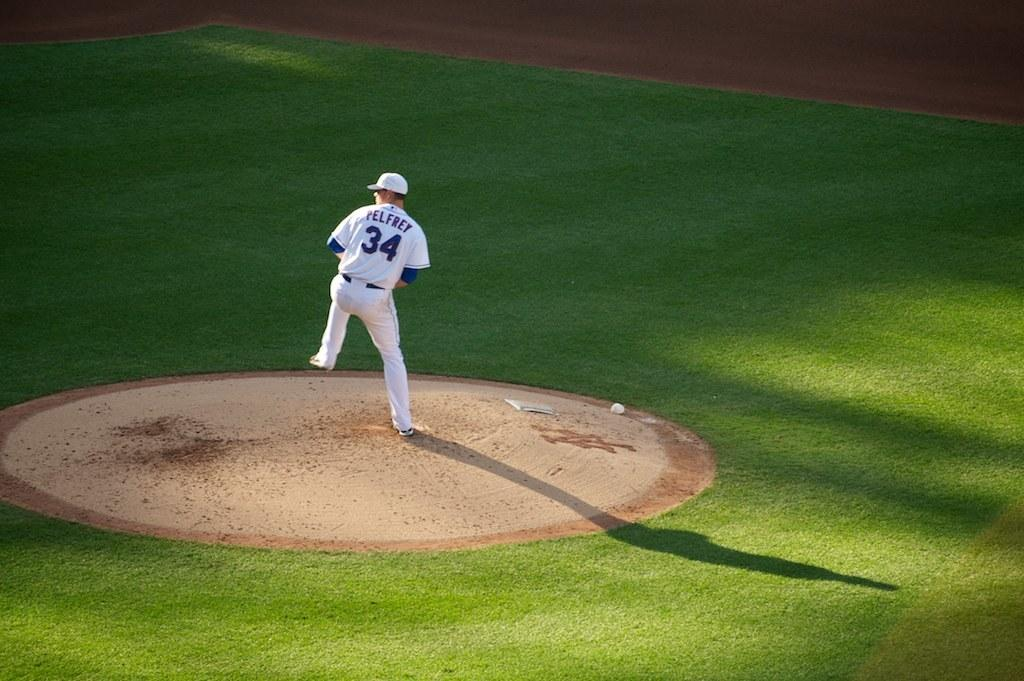<image>
Create a compact narrative representing the image presented. A pitcher with no. 34 is about to step into his pitch. 